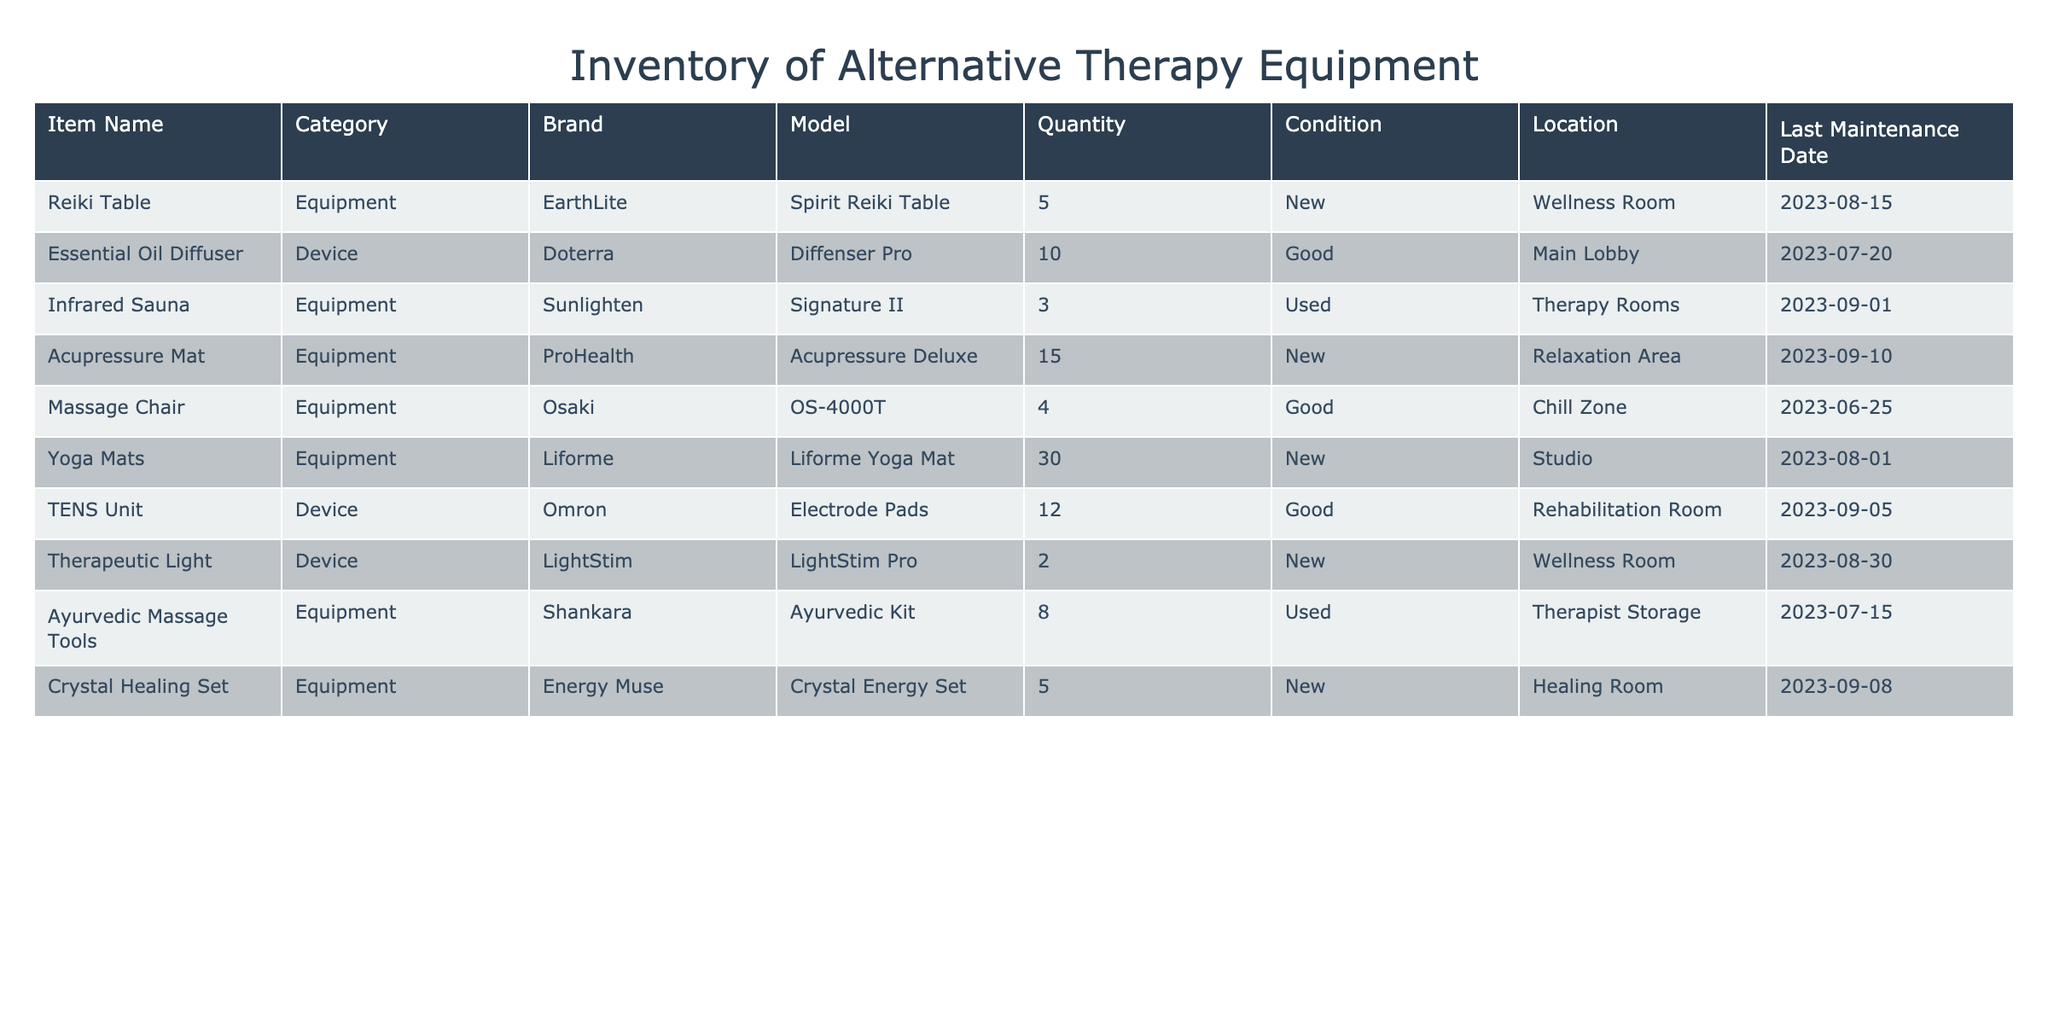What is the quantity of Yoga Mats in inventory? The table directly lists the quantity of Yoga Mats, which is stated under the 'Quantity' column for this item. Upon checking, the quantity is 30.
Answer: 30 How many pieces of therapeutic equipment are in 'New' condition? By scanning the 'Condition' column, we identify the items marked as 'New': Reiki Table, Acupressure Mat, Yoga Mats, Therapeutic Light, and Crystal Healing Set. Counting these gives us a total of 5 pieces of equipment.
Answer: 5 Is there any device in the inventory that has a 'Used' condition? Checking the 'Condition' column, the Infrared Sauna and Ayurvedic Massage Tools are listed as 'Used'. The presence of these items confirms that there are devices in 'Used' condition.
Answer: Yes What is the total quantity of equipment located in the Therapy Rooms? The table shows one item located in the Therapy Rooms: the Infrared Sauna, which has a quantity of 3. Therefore, the total quantity is simply the quantity of that specific item.
Answer: 3 Which equipment has the most quantity available in inventory? By examining the 'Quantity' column, we find that Yoga Mats have the highest quantity at 30. We verify that no other items exceed this quantity.
Answer: Yoga Mats What is the average quantity of equipment across all items listed in the inventory? To calculate the average quantity, we sum all quantities (5 + 10 + 3 + 15 + 4 + 30 + 12 + 2 + 8 + 5 = 89) and divide by the total number of items (10). The average is 89/10 = 8.9.
Answer: 8.9 Are there more Essential Oil Diffusers than TENS Units in inventory? The table lists 10 Essential Oil Diffusers and 12 TENS Units. Comparing these two values shows that TENS Units outnumber Essential Oil Diffusers.
Answer: No Which brand has the highest number of devices categorized as 'Device'? Looking at the 'Device' category, we identify Doterra (10 - Essential Oil Diffusers), Omron (12 - TENS Units), and LightStim (2 - Therapeutic Lights). Omron has the highest quantity with 12 devices.
Answer: Omron 